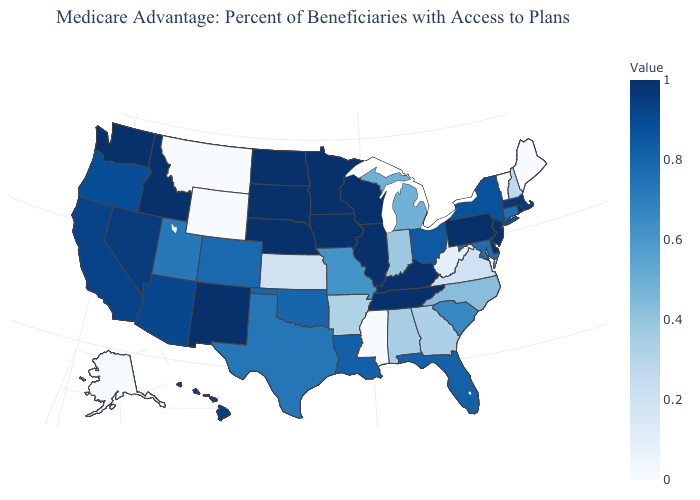Does Kansas have a lower value than Missouri?
Be succinct. Yes. Does the map have missing data?
Short answer required. No. Does Mississippi have the lowest value in the South?
Give a very brief answer. Yes. Does the map have missing data?
Give a very brief answer. No. Among the states that border New Hampshire , does Massachusetts have the lowest value?
Answer briefly. No. 